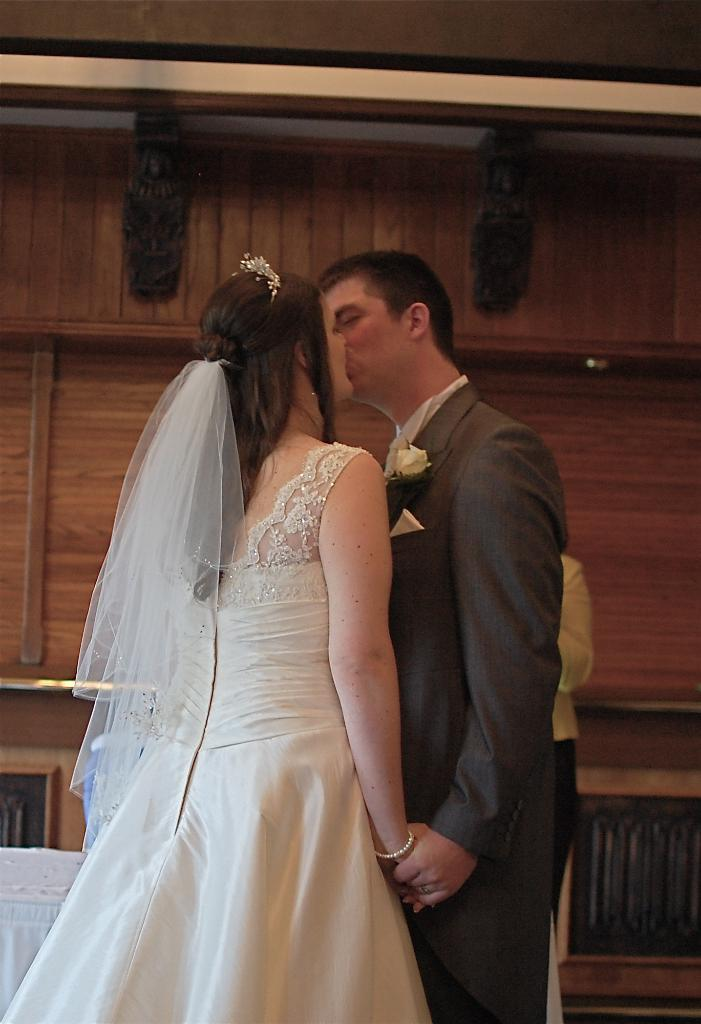How many people are in the image? There are two people in the image, a man and a woman. What is the woman wearing on her head? The woman is wearing a crown and a veil. What can be seen on the man's coat? The man has a flower on his coat. What type of wall is visible in the background of the image? There is a wooden wall in the background of the image. How many boats are visible in the image? There are no boats present in the image. Is there a drain visible in the image? There is no drain present in the image. 